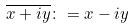<formula> <loc_0><loc_0><loc_500><loc_500>\overline { x + i y } \colon = x - i y</formula> 